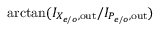Convert formula to latex. <formula><loc_0><loc_0><loc_500><loc_500>\arctan ( I _ { X _ { e / o } , o u t } / I _ { P _ { e / o } , o u t } )</formula> 